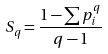Convert formula to latex. <formula><loc_0><loc_0><loc_500><loc_500>S _ { q } = \frac { 1 - \sum p _ { i } ^ { q } } { q - 1 }</formula> 